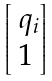Convert formula to latex. <formula><loc_0><loc_0><loc_500><loc_500>\begin{bmatrix} \ q _ { i } \\ 1 \end{bmatrix}</formula> 